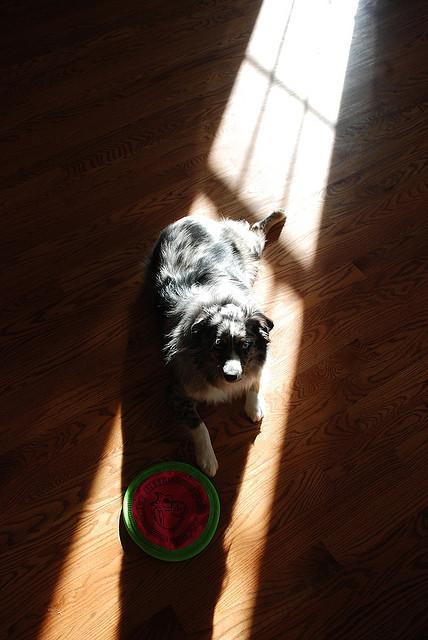How many donuts are there?
Give a very brief answer. 0. 